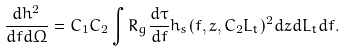Convert formula to latex. <formula><loc_0><loc_0><loc_500><loc_500>\frac { d h ^ { 2 } } { d f d \Omega } = C _ { 1 } C _ { 2 } \int R _ { g } \frac { d \tau } { d f } h _ { s } ( f , z , C _ { 2 } L _ { t } ) ^ { 2 } d z d L _ { t } d f .</formula> 